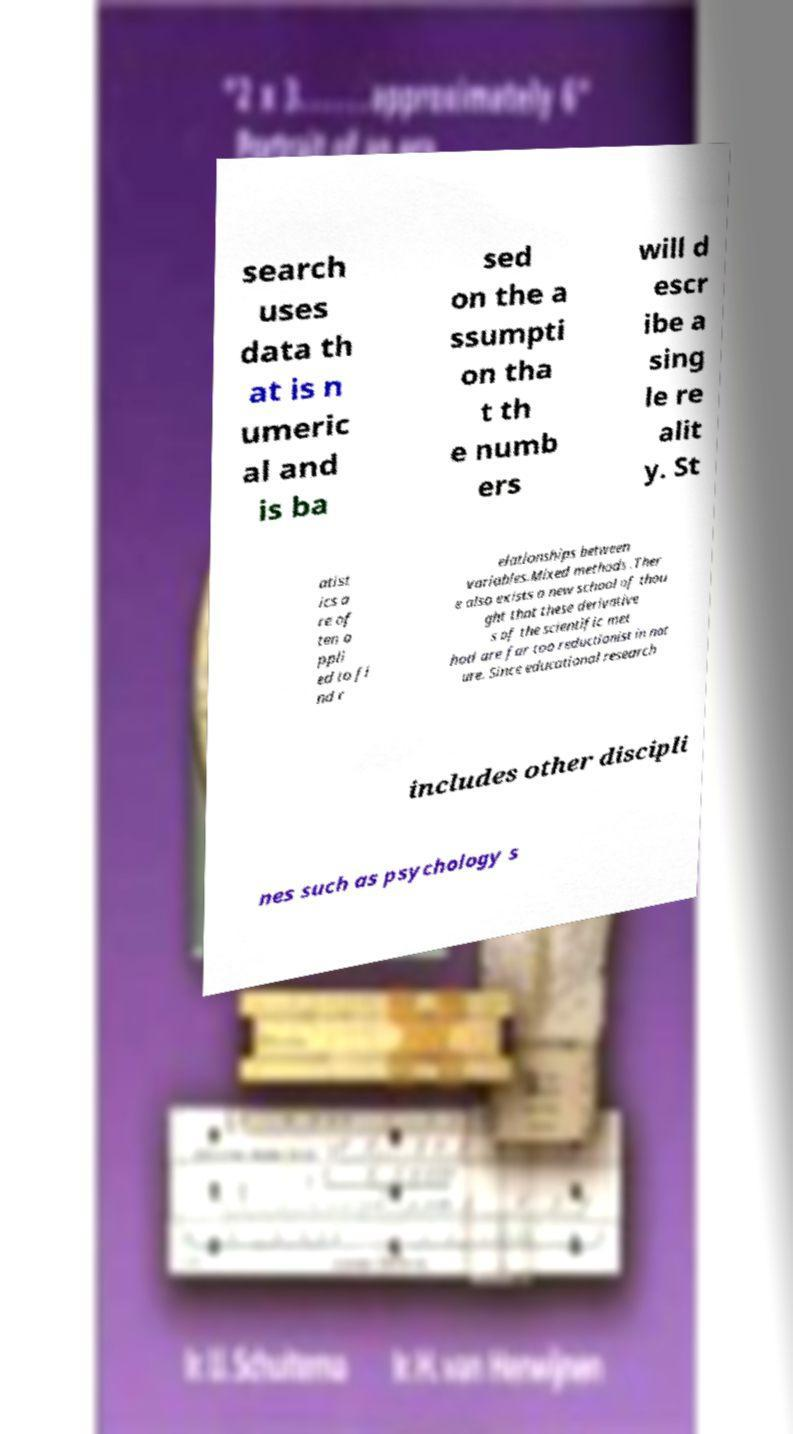There's text embedded in this image that I need extracted. Can you transcribe it verbatim? search uses data th at is n umeric al and is ba sed on the a ssumpti on tha t th e numb ers will d escr ibe a sing le re alit y. St atist ics a re of ten a ppli ed to fi nd r elationships between variables.Mixed methods .Ther e also exists a new school of thou ght that these derivative s of the scientific met hod are far too reductionist in nat ure. Since educational research includes other discipli nes such as psychology s 